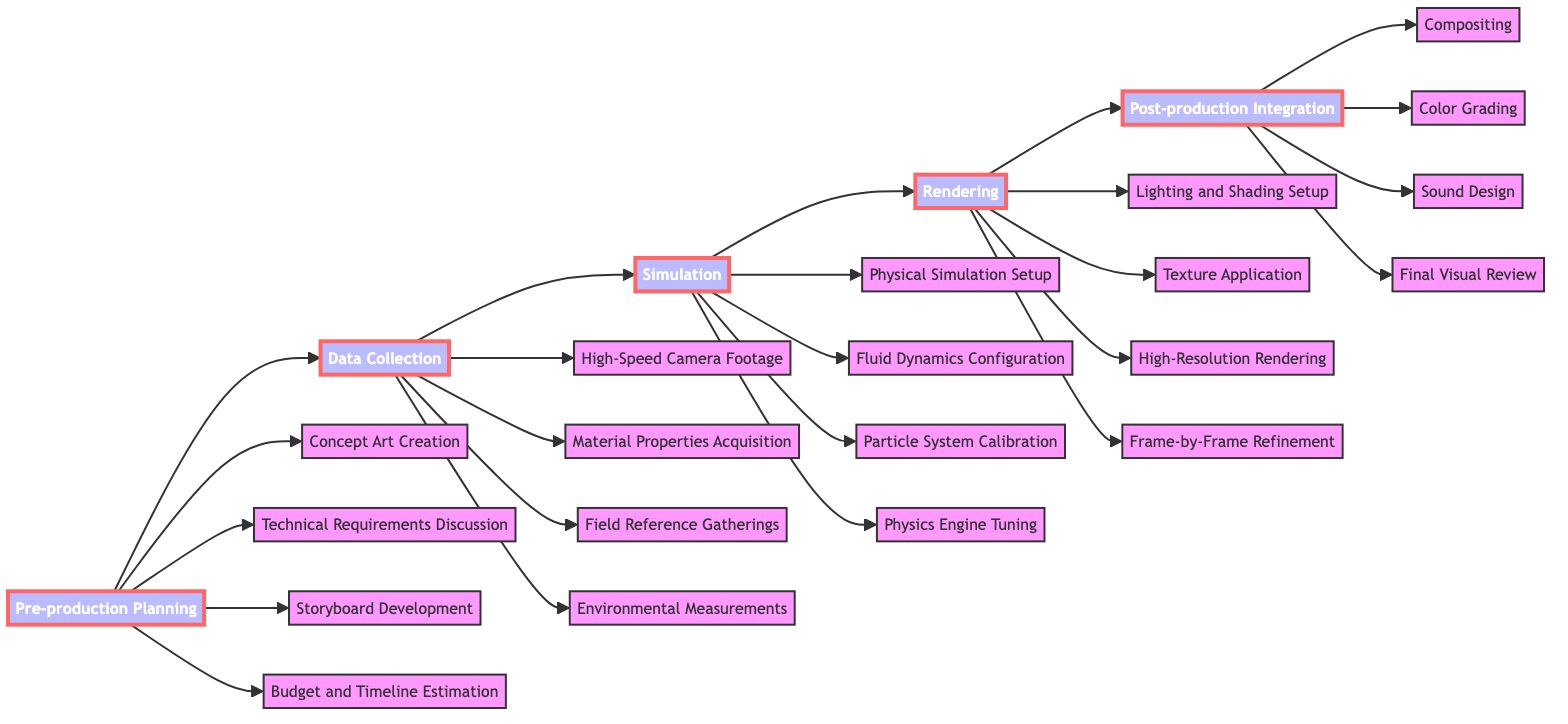What is the first step in the pipeline? The first step can be found by looking at the leftmost node in the flowchart, which is "Pre-production Planning."
Answer: Pre-production Planning How many steps are there in the Data Collection phase? To determine this, count the nodes listed under "Data Collection" in the diagram: High-Speed Camera Footage, Material Properties Acquisition, Field Reference Gatherings, Environmental Measurements. This totals four steps.
Answer: 4 What follows the Simulation phase? The flowchart indicates that the step immediately after "Simulation" is "Rendering."
Answer: Rendering Which node is a part of the Rendering phase? Review the nodes under "Rendering:" Lighting and Shading Setup, Texture Application, High-Resolution Rendering, Frame-by-Frame Refinement. Any of these can be considered, but only one name is needed, so we can take the first one.
Answer: Lighting and Shading Setup What are the last two steps in the pipeline? By identifying the final two nodes in the flowchart, we can see that they are "Sound Design" and "Final Visual Review," as they are the last two listed under "Post-production Integration."
Answer: Sound Design, Final Visual Review Which phase includes "Physics Engine Tuning"? Look in the "Simulation" section of the diagram where "Physics Engine Tuning" is located. This indicates that it's part of the Simulation phase.
Answer: Simulation How many total phases are represented in the pipeline? Count the distinct phases present in the pipeline: Pre-production Planning, Data Collection, Simulation, Rendering, Post-production Integration. This gives a total of five phases.
Answer: 5 What is the relationship between "Technical Requirements Discussion" and "Field Reference Gatherings"? Analyze the flowchart to see that these two nodes belong to different phases: "Technical Requirements Discussion" is under "Pre-production Planning," while "Field Reference Gatherings" is under "Data Collection." Therefore, they are sequential steps in the pipeline.
Answer: Sequential Which step involves creating concept art? The diagram indicates that "Concept Art Creation" is specifically mentioned under "Pre-production Planning."
Answer: Concept Art Creation 